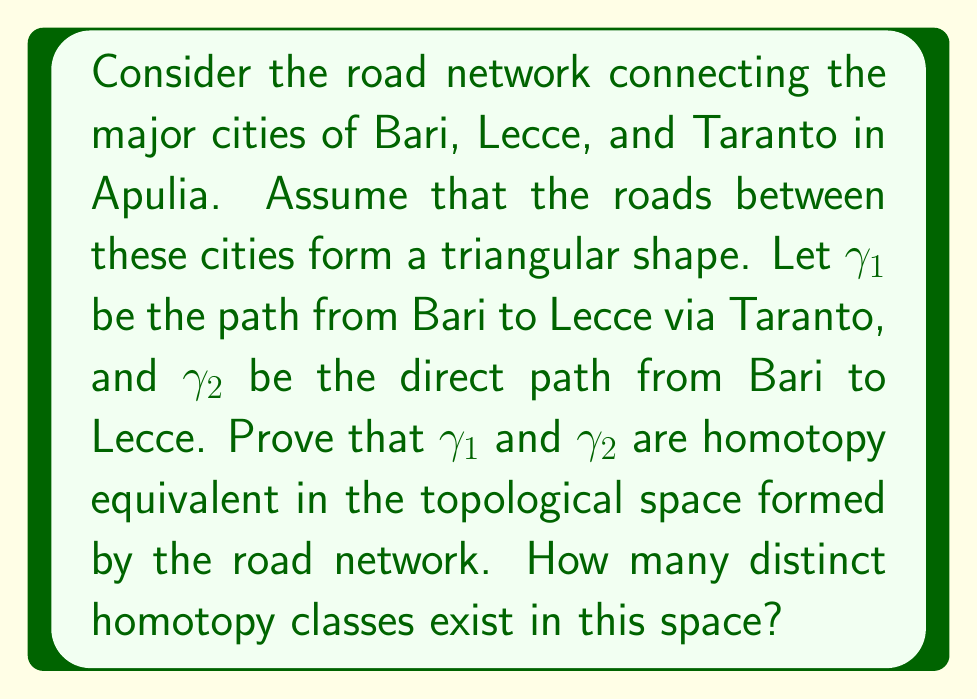What is the answer to this math problem? To prove that $\gamma_1$ and $\gamma_2$ are homotopy equivalent and determine the number of distinct homotopy classes, we'll follow these steps:

1) First, let's visualize the road network:

[asy]
unitsize(1cm);
pair A = (0,0), B = (4,0), C = (2,3);
draw(A--B--C--A);
label("Bari", A, SW);
label("Lecce", B, SE);
label("Taranto", C, N);
draw(A--B, dashed);
label("$\gamma_2$", (2,-0.3));
path g1 = A--C--B;
draw(g1, arrow=Arrow(TeXHead));
label("$\gamma_1$", g1, N);
[/asy]

2) The road network forms a simply connected space, as it's topologically equivalent to a disc.

3) In a simply connected space, any two paths with the same endpoints are homotopy equivalent. This is because we can continuously deform one path into the other without leaving the space.

4) We can define a homotopy $H: [0,1] \times [0,1] \to X$ (where $X$ is our road network) between $\gamma_1$ and $\gamma_2$ as follows:

   $H(s,t) = (1-t)\gamma_1(s) + t\gamma_2(s)$

   This homotopy smoothly transitions from $\gamma_1$ when $t=0$ to $\gamma_2$ when $t=1$.

5) Since we can construct this homotopy, $\gamma_1$ and $\gamma_2$ are indeed homotopy equivalent.

6) In a simply connected space, all loops are contractible to a point. This means that any closed path can be continuously shrunk to a single point within the space.

7) As a result, there is only one homotopy class in this space - the class containing all paths. Any two paths with the same endpoints can be deformed into each other.

Therefore, $\gamma_1$ and $\gamma_2$ are homotopy equivalent, and there is only one distinct homotopy class in this space.
Answer: $\gamma_1$ and $\gamma_2$ are homotopy equivalent. There is only 1 distinct homotopy class in this space. 